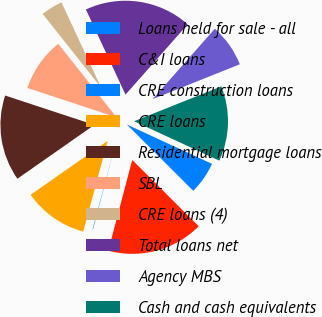<chart> <loc_0><loc_0><loc_500><loc_500><pie_chart><fcel>Loans held for sale - all<fcel>C&I loans<fcel>CRE construction loans<fcel>CRE loans<fcel>Residential mortgage loans<fcel>SBL<fcel>CRE loans (4)<fcel>Total loans net<fcel>Agency MBS<fcel>Cash and cash equivalents<nl><fcel>5.59%<fcel>16.62%<fcel>0.08%<fcel>11.1%<fcel>14.78%<fcel>9.26%<fcel>3.75%<fcel>18.45%<fcel>7.43%<fcel>12.94%<nl></chart> 